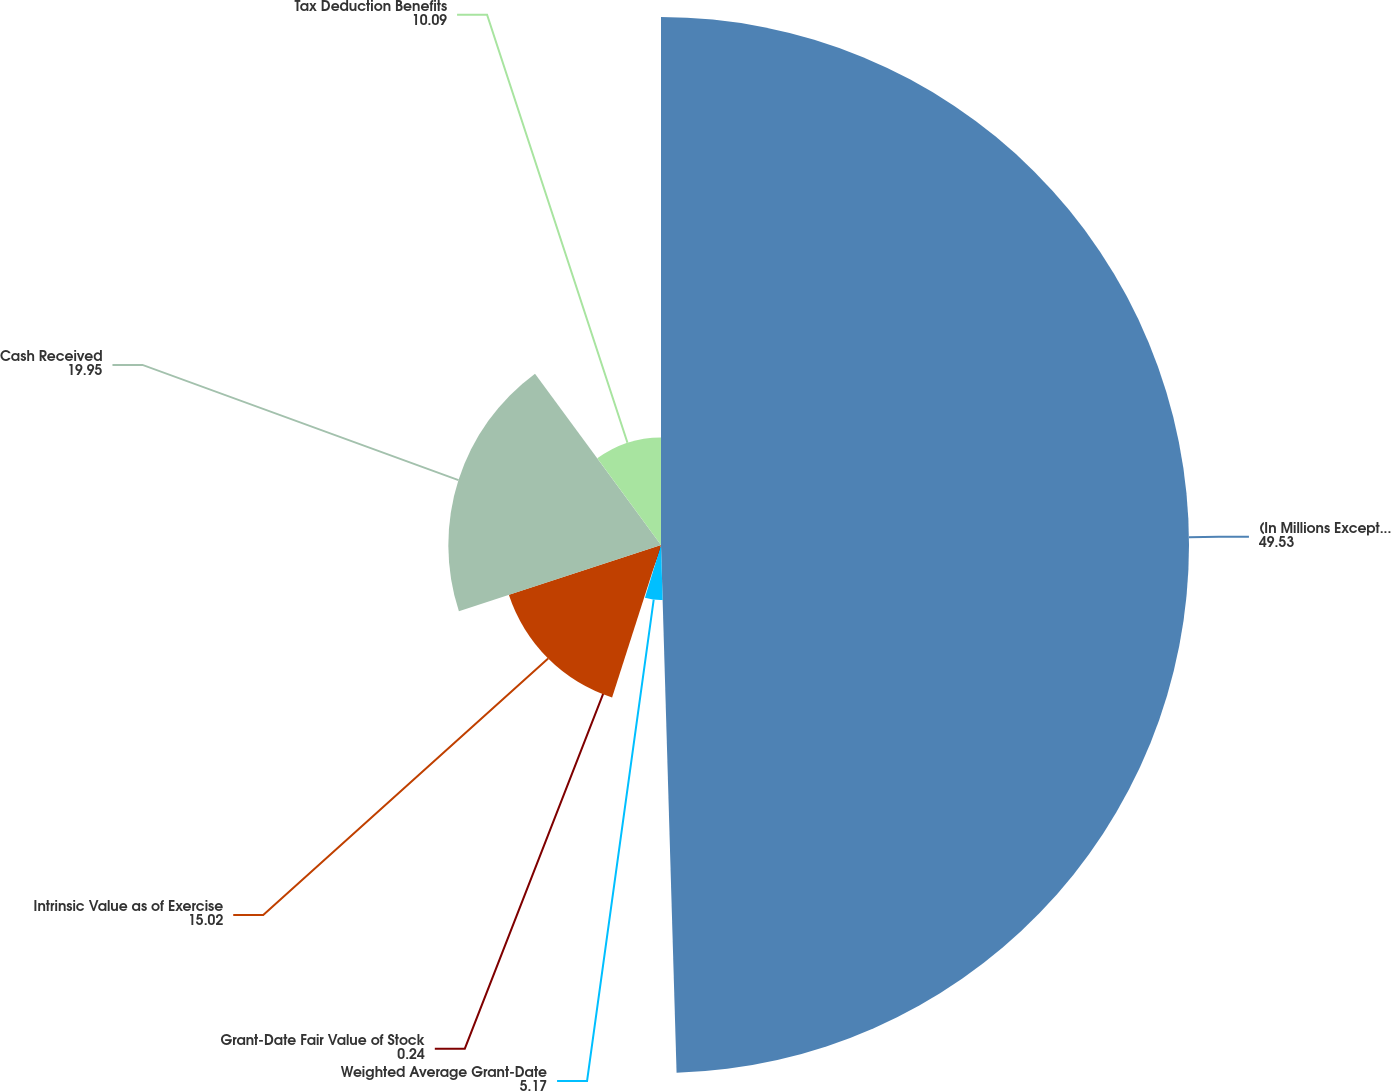<chart> <loc_0><loc_0><loc_500><loc_500><pie_chart><fcel>(In Millions Except Per Share<fcel>Weighted Average Grant-Date<fcel>Grant-Date Fair Value of Stock<fcel>Intrinsic Value as of Exercise<fcel>Cash Received<fcel>Tax Deduction Benefits<nl><fcel>49.53%<fcel>5.17%<fcel>0.24%<fcel>15.02%<fcel>19.95%<fcel>10.09%<nl></chart> 